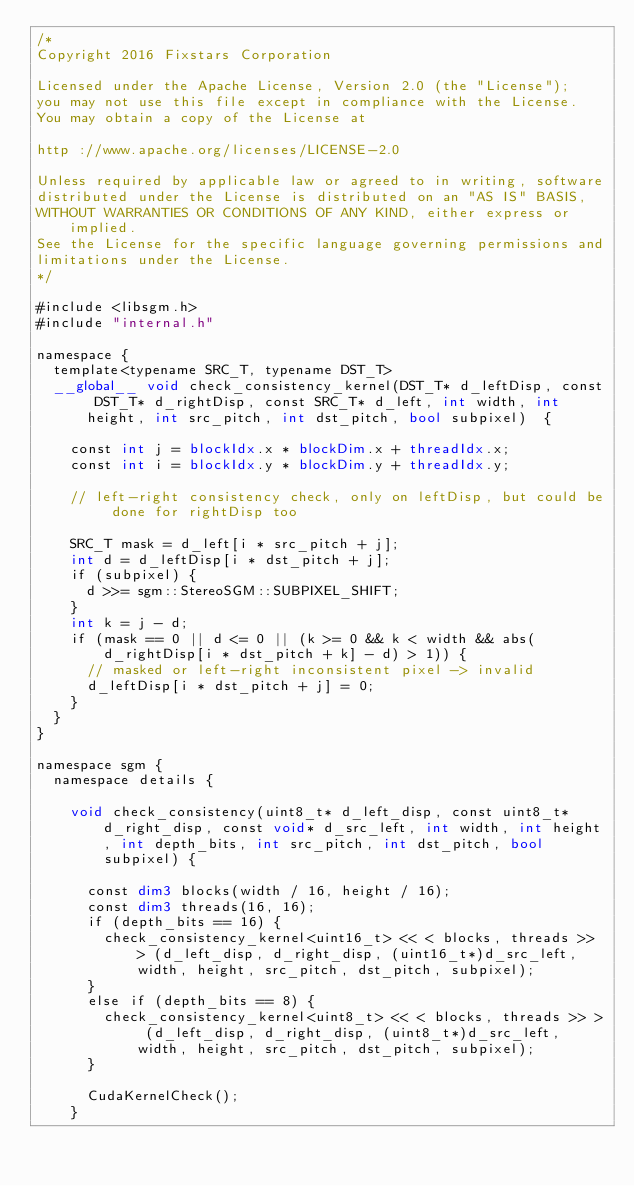<code> <loc_0><loc_0><loc_500><loc_500><_Cuda_>/*
Copyright 2016 Fixstars Corporation

Licensed under the Apache License, Version 2.0 (the "License");
you may not use this file except in compliance with the License.
You may obtain a copy of the License at

http ://www.apache.org/licenses/LICENSE-2.0

Unless required by applicable law or agreed to in writing, software
distributed under the License is distributed on an "AS IS" BASIS,
WITHOUT WARRANTIES OR CONDITIONS OF ANY KIND, either express or implied.
See the License for the specific language governing permissions and
limitations under the License.
*/

#include <libsgm.h>
#include "internal.h"

namespace {
	template<typename SRC_T, typename DST_T>
	__global__ void check_consistency_kernel(DST_T* d_leftDisp, const DST_T* d_rightDisp, const SRC_T* d_left, int width, int height, int src_pitch, int dst_pitch, bool subpixel)  {

		const int j = blockIdx.x * blockDim.x + threadIdx.x;
		const int i = blockIdx.y * blockDim.y + threadIdx.y;

		// left-right consistency check, only on leftDisp, but could be done for rightDisp too

		SRC_T mask = d_left[i * src_pitch + j];
		int d = d_leftDisp[i * dst_pitch + j];
		if (subpixel) {
			d >>= sgm::StereoSGM::SUBPIXEL_SHIFT;
		}
		int k = j - d;
		if (mask == 0 || d <= 0 || (k >= 0 && k < width && abs(d_rightDisp[i * dst_pitch + k] - d) > 1)) {
			// masked or left-right inconsistent pixel -> invalid
			d_leftDisp[i * dst_pitch + j] = 0;
		}
	}
}

namespace sgm {
	namespace details {

		void check_consistency(uint8_t* d_left_disp, const uint8_t* d_right_disp, const void* d_src_left, int width, int height, int depth_bits, int src_pitch, int dst_pitch, bool subpixel) {

			const dim3 blocks(width / 16, height / 16);
			const dim3 threads(16, 16);
			if (depth_bits == 16) {
				check_consistency_kernel<uint16_t> << < blocks, threads >> > (d_left_disp, d_right_disp, (uint16_t*)d_src_left, width, height, src_pitch, dst_pitch, subpixel);
			}
			else if (depth_bits == 8) {
				check_consistency_kernel<uint8_t> << < blocks, threads >> > (d_left_disp, d_right_disp, (uint8_t*)d_src_left, width, height, src_pitch, dst_pitch, subpixel);
			}

			CudaKernelCheck();
		}
</code> 